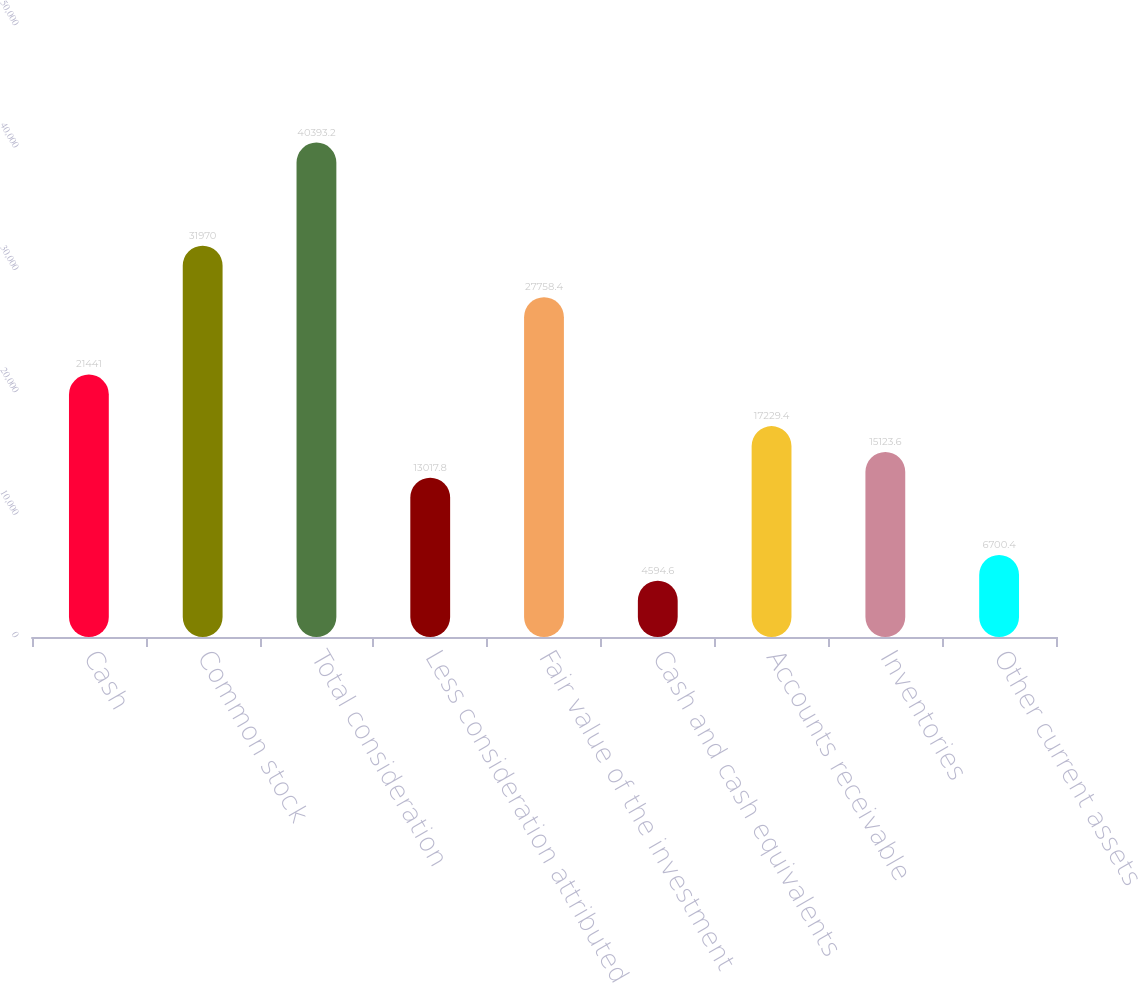<chart> <loc_0><loc_0><loc_500><loc_500><bar_chart><fcel>Cash<fcel>Common stock<fcel>Total consideration<fcel>Less consideration attributed<fcel>Fair value of the investment<fcel>Cash and cash equivalents<fcel>Accounts receivable<fcel>Inventories<fcel>Other current assets<nl><fcel>21441<fcel>31970<fcel>40393.2<fcel>13017.8<fcel>27758.4<fcel>4594.6<fcel>17229.4<fcel>15123.6<fcel>6700.4<nl></chart> 